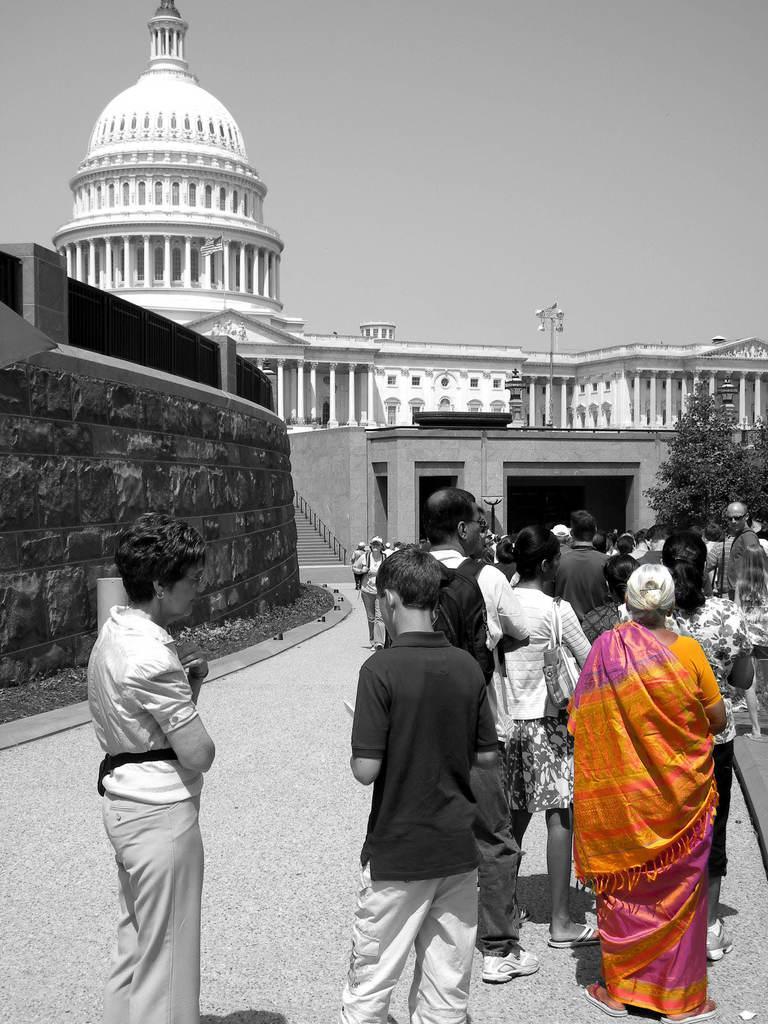Please provide a concise description of this image. In this image we can see the building, there is a brick wall, trees, grass, stairs, road, few people standing, we can see the sky. 